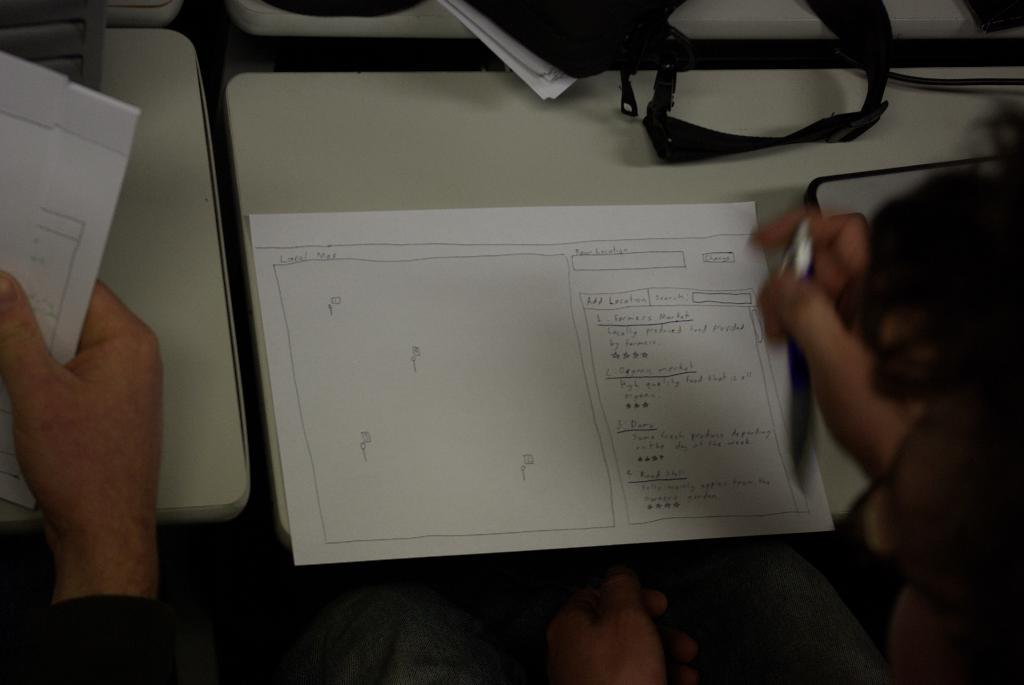How many people are in the image? There are two people in the image. What are the people holding in their hands? The people are holding papers and a pen. What is in front of the people? There is a table in front of the people. What can be seen on the table? There is a black color bag and a white color paper on the table. How far can the people kick the ball in the image? There is no ball present in the image, so it is not possible to determine how far the people can kick a ball. 